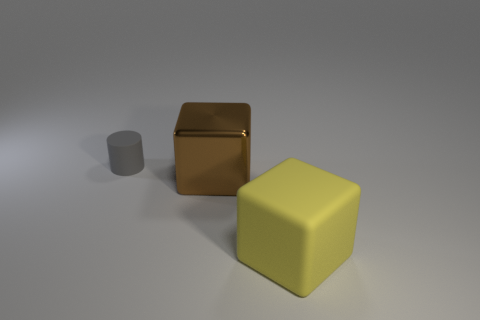Subtract 2 blocks. How many blocks are left? 0 Add 1 tiny gray objects. How many objects exist? 4 Subtract all cylinders. How many objects are left? 2 Add 2 yellow matte blocks. How many yellow matte blocks are left? 3 Add 2 cyan matte spheres. How many cyan matte spheres exist? 2 Subtract 0 green balls. How many objects are left? 3 Subtract all purple cylinders. Subtract all purple balls. How many cylinders are left? 1 Subtract all yellow things. Subtract all tiny gray objects. How many objects are left? 1 